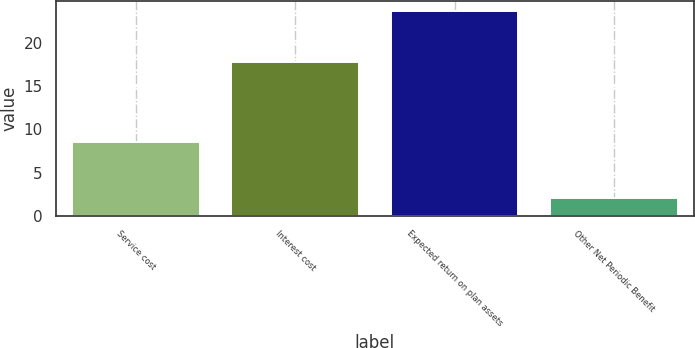<chart> <loc_0><loc_0><loc_500><loc_500><bar_chart><fcel>Service cost<fcel>Interest cost<fcel>Expected return on plan assets<fcel>Other Net Periodic Benefit<nl><fcel>8.5<fcel>17.8<fcel>23.7<fcel>2<nl></chart> 